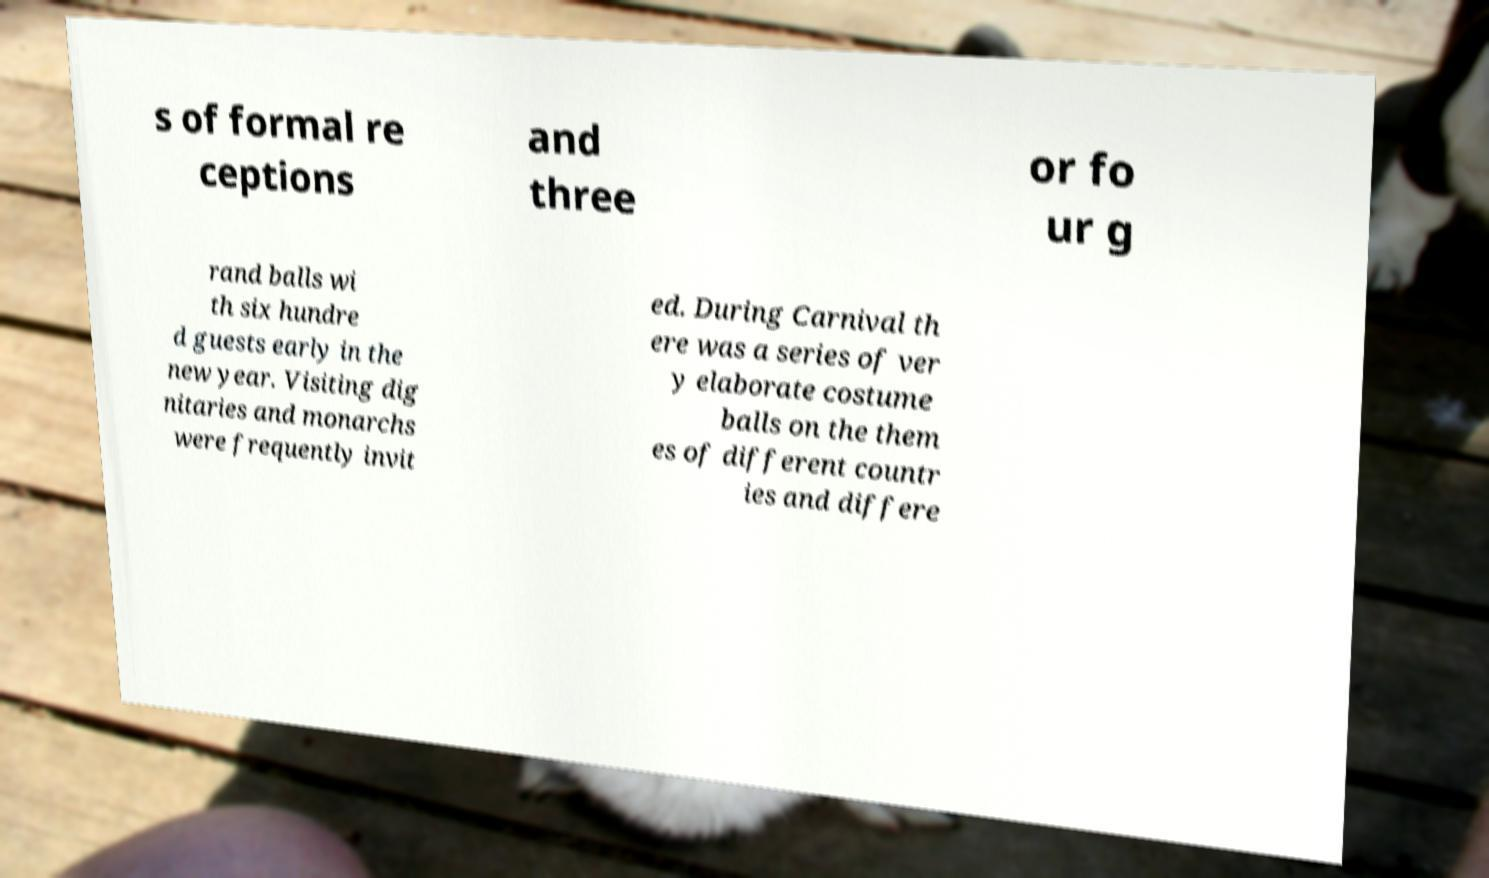Please identify and transcribe the text found in this image. s of formal re ceptions and three or fo ur g rand balls wi th six hundre d guests early in the new year. Visiting dig nitaries and monarchs were frequently invit ed. During Carnival th ere was a series of ver y elaborate costume balls on the them es of different countr ies and differe 